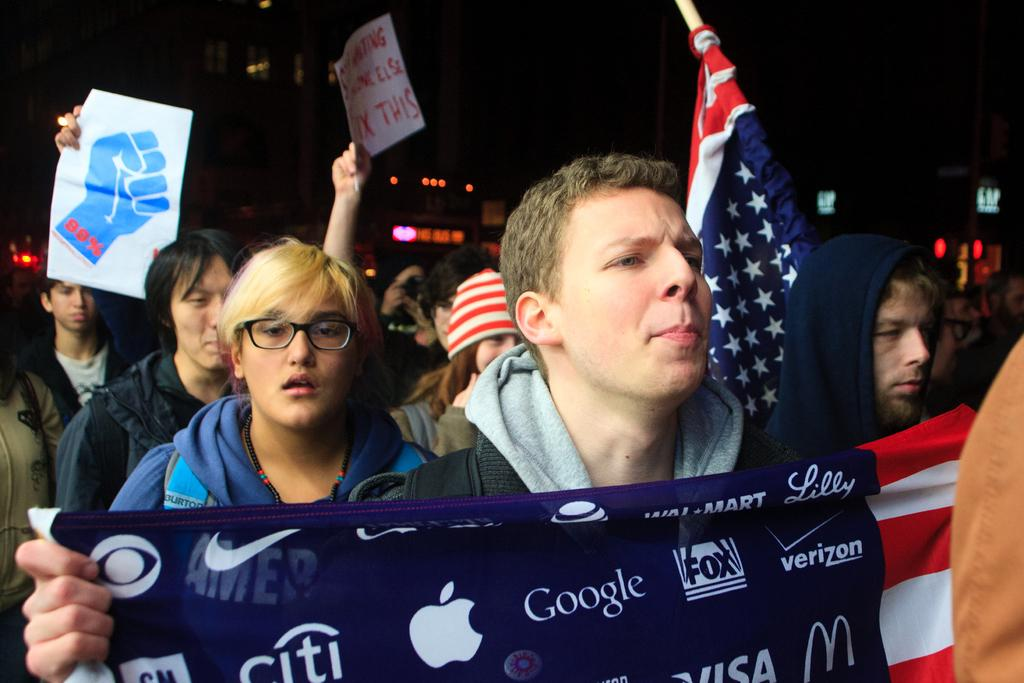What can be seen in the foreground of the picture? There are people in the foreground of the picture. What are the people holding in the image? The people are holding flags and placards. What is visible in the background of the image? The background of the image is blurred, but there are buildings and lights visible. How many balloons are tied to the cow in the image? There is no cow or balloons present in the image. What is the aftermath of the event depicted in the image? The image does not depict an event or its aftermath; it simply shows people holding flags and placards with a blurred background. 